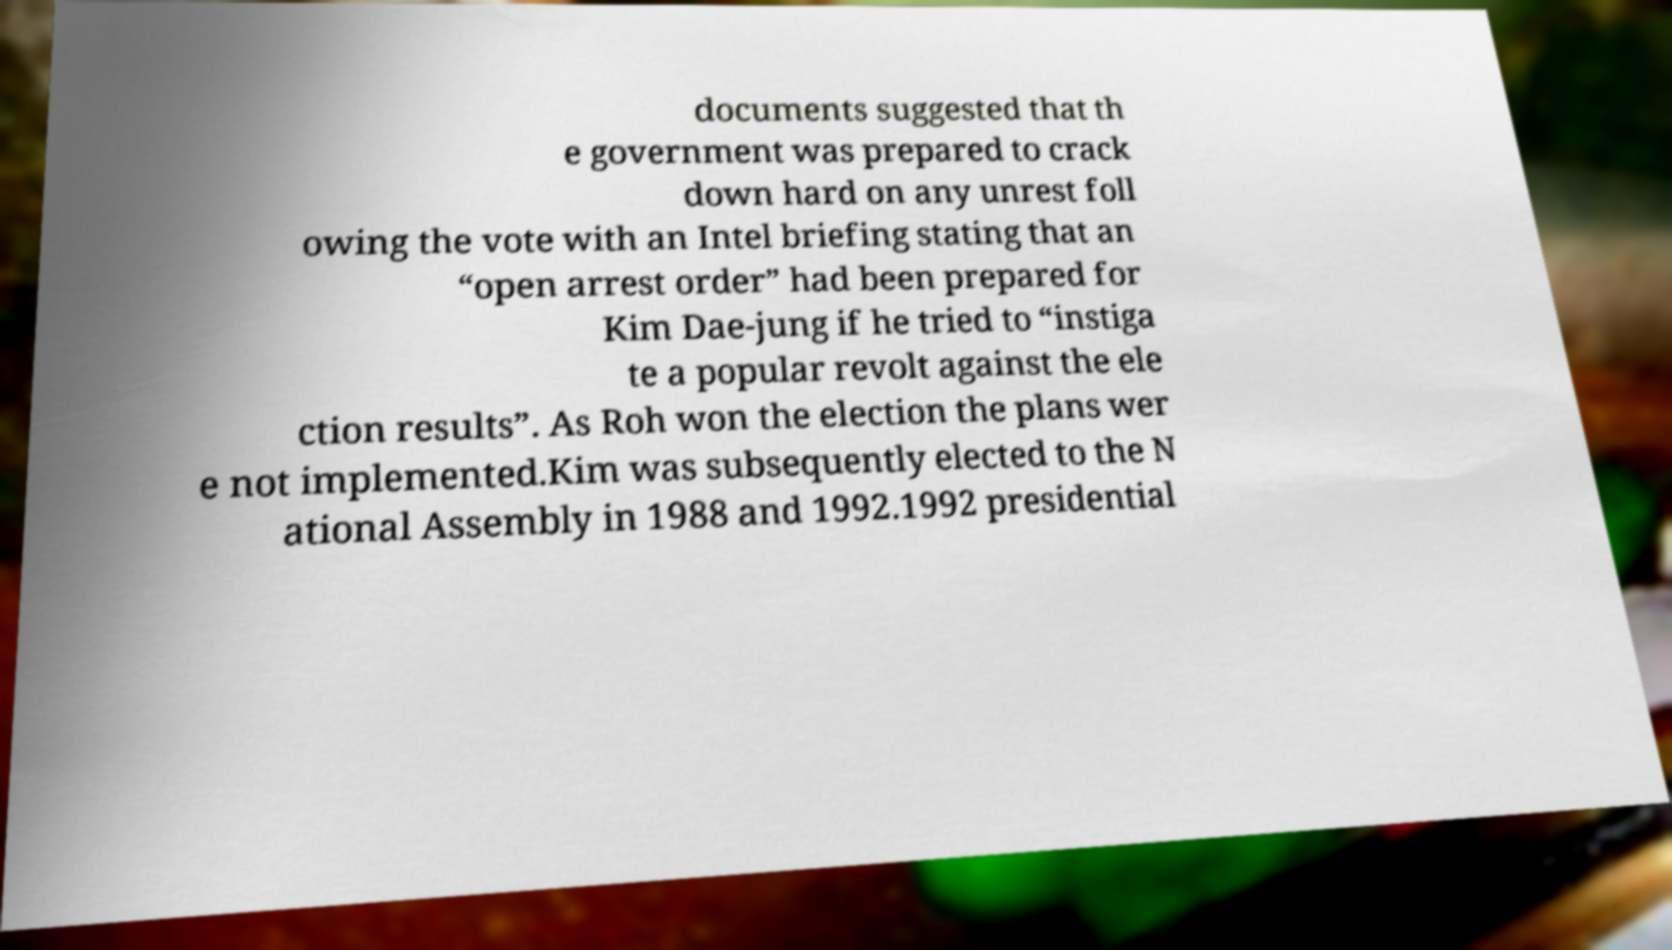For documentation purposes, I need the text within this image transcribed. Could you provide that? documents suggested that th e government was prepared to crack down hard on any unrest foll owing the vote with an Intel briefing stating that an “open arrest order” had been prepared for Kim Dae-jung if he tried to “instiga te a popular revolt against the ele ction results”. As Roh won the election the plans wer e not implemented.Kim was subsequently elected to the N ational Assembly in 1988 and 1992.1992 presidential 